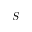Convert formula to latex. <formula><loc_0><loc_0><loc_500><loc_500>S</formula> 